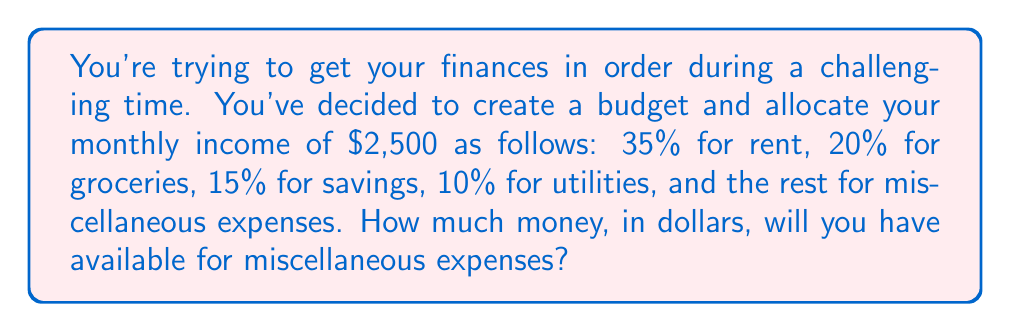What is the answer to this math problem? Let's break this down step-by-step:

1. First, let's calculate the percentages allocated for specific categories:
   Rent: 35%
   Groceries: 20%
   Savings: 15%
   Utilities: 10%
   Total allocated: $35\% + 20\% + 15\% + 10\% = 80\%$

2. The percentage left for miscellaneous expenses:
   $100\% - 80\% = 20\%$

3. Now, let's calculate the dollar amount for miscellaneous expenses:
   Total monthly income: $2,500
   Percentage for miscellaneous: 20%

   To calculate the dollar amount, we use the formula:
   $\text{Amount} = \text{Total} \times \frac{\text{Percentage}}{100}$

   $\text{Miscellaneous Amount} = \$2,500 \times \frac{20}{100} = \$2,500 \times 0.20 = \$500$

Therefore, you will have $500 available for miscellaneous expenses.
Answer: $500 